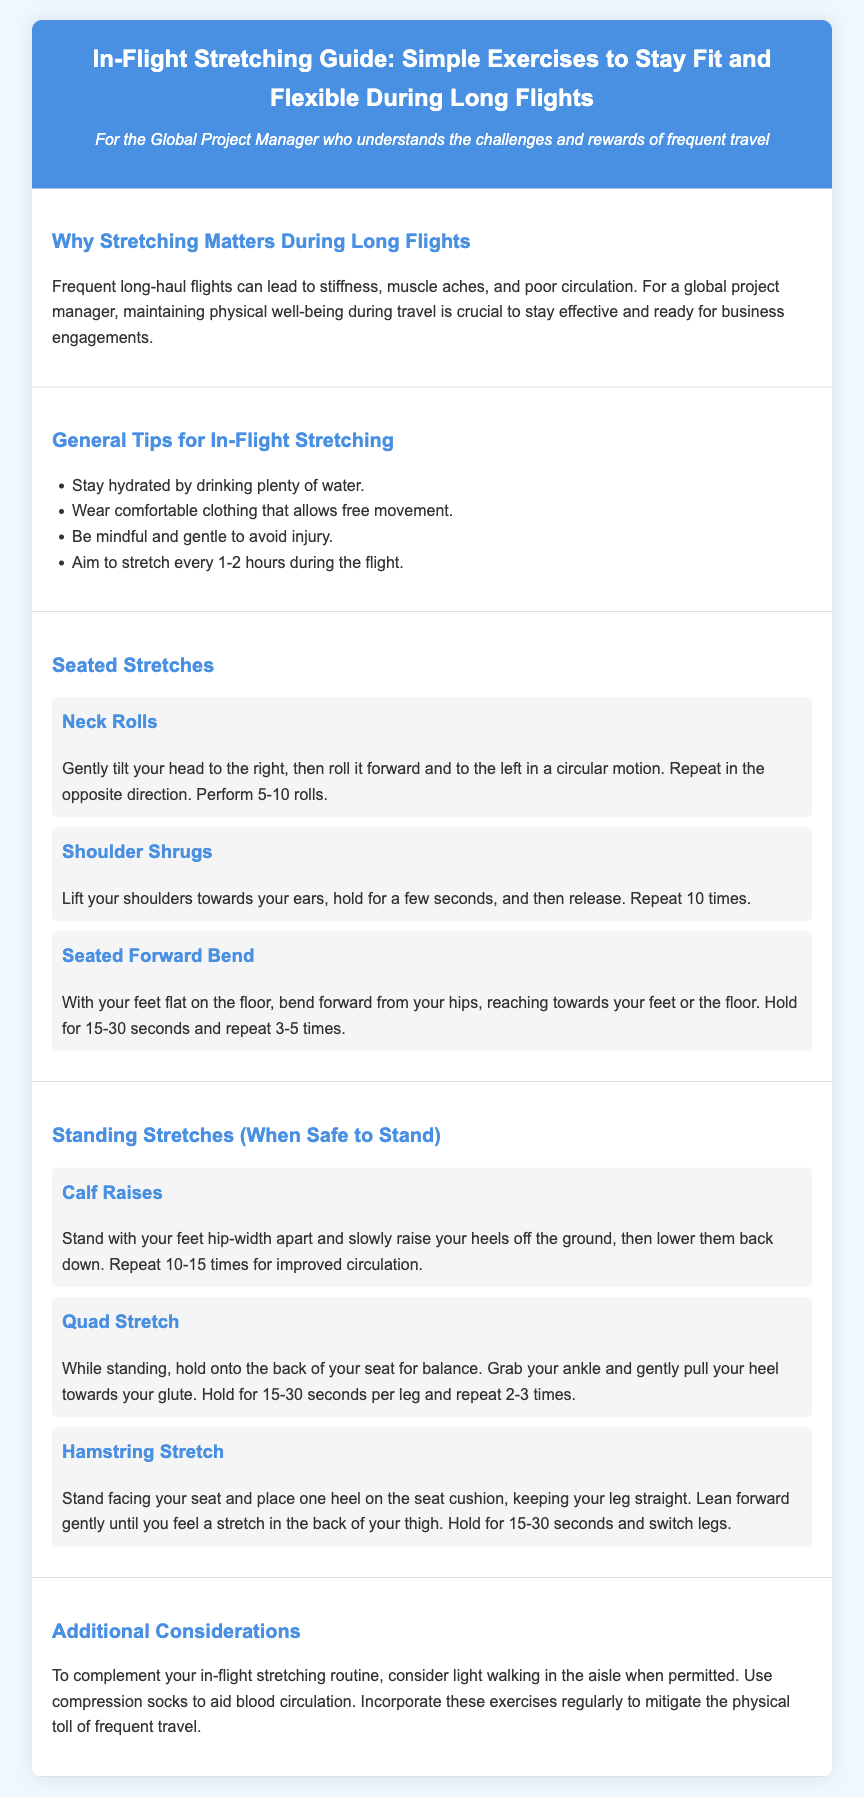What is the main benefit of stretching during long flights? The document states that stretching helps to combat stiffness, muscle aches, and poor circulation during long flights.
Answer: Combat stiffness, muscle aches, and poor circulation How often should you stretch during a flight? The document recommends stretching every 1-2 hours during the flight.
Answer: Every 1-2 hours What is the first seated stretch mentioned? The first seated stretch listed in the document is "Neck Rolls."
Answer: Neck Rolls How many times should you repeat shoulder shrugs? The document instructs to repeat shoulder shrugs 10 times.
Answer: 10 times What exercise should you perform while standing? The document mentions several standing stretches; one example is "Calf Raises."
Answer: Calf Raises What additional equipment is suggested to aid circulation? The document suggests using compression socks to aid blood circulation.
Answer: Compression socks What is a key tip for comfortable in-flight stretching? The document advises wearing comfortable clothing that allows free movement.
Answer: Comfortable clothing What should you do when permitted during the flight? The document encourages light walking in the aisle when permitted.
Answer: Light walking in the aisle 